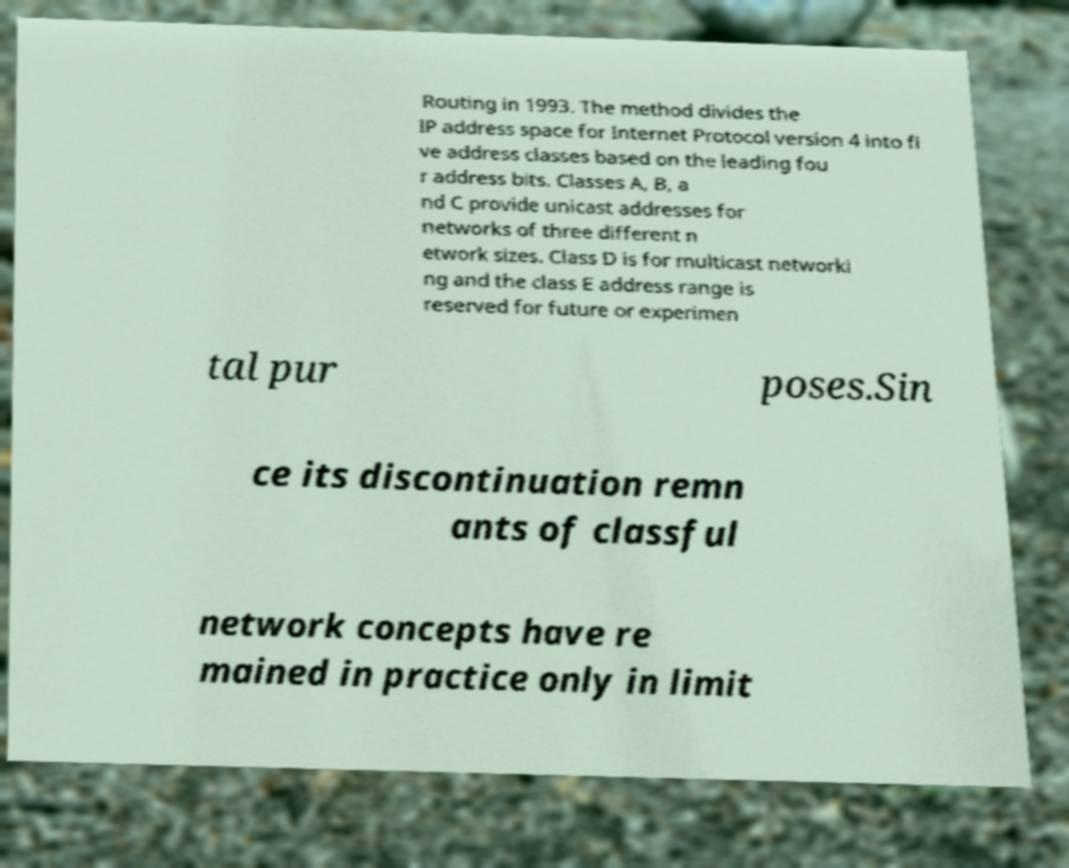For documentation purposes, I need the text within this image transcribed. Could you provide that? Routing in 1993. The method divides the IP address space for Internet Protocol version 4 into fi ve address classes based on the leading fou r address bits. Classes A, B, a nd C provide unicast addresses for networks of three different n etwork sizes. Class D is for multicast networki ng and the class E address range is reserved for future or experimen tal pur poses.Sin ce its discontinuation remn ants of classful network concepts have re mained in practice only in limit 